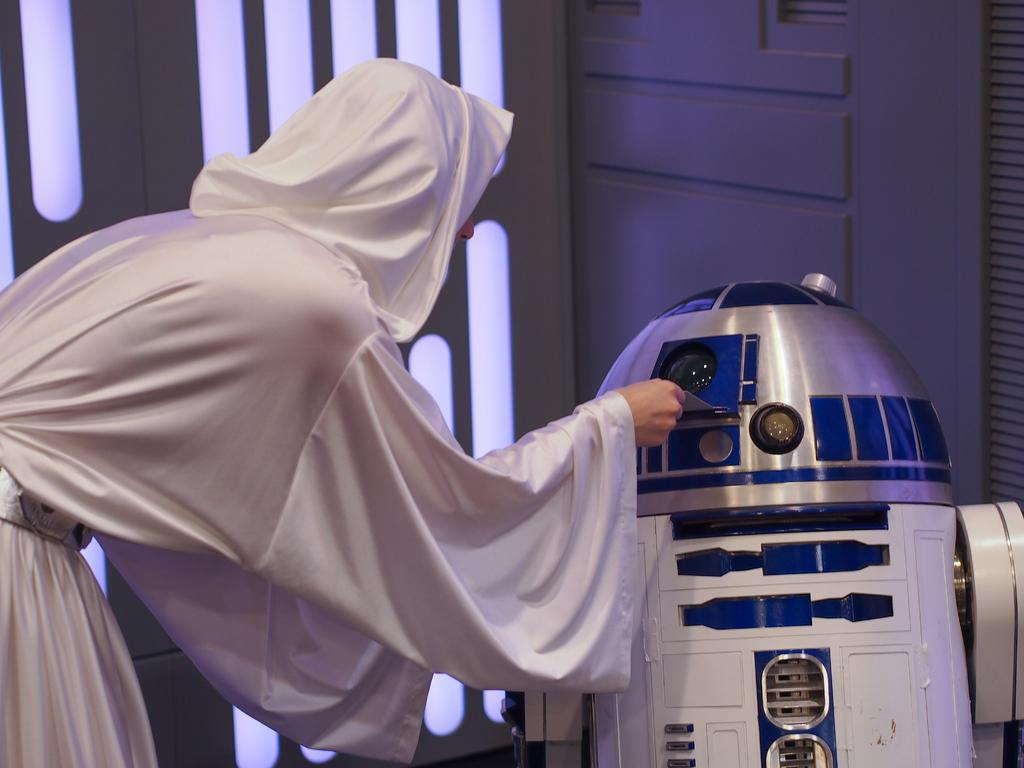What is the person in the image doing? The person is standing in the image and placing something into a machine. Can you describe the machine in the image? The machine is in front of the person and is the object into which they are placing something. What is visible in the background of the image? There is a wall in the background of the image. What type of lettuce is being processed by the person in the image? There is no lettuce or processing activity present in the image. The person is placing something into a machine, but the nature of the object and the purpose of the machine are not specified in the provided facts. 